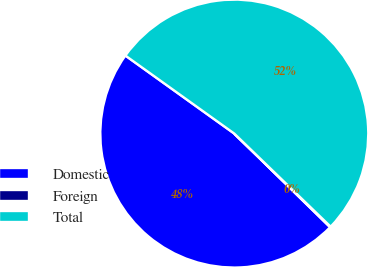Convert chart. <chart><loc_0><loc_0><loc_500><loc_500><pie_chart><fcel>Domestic<fcel>Foreign<fcel>Total<nl><fcel>47.58%<fcel>0.09%<fcel>52.33%<nl></chart> 